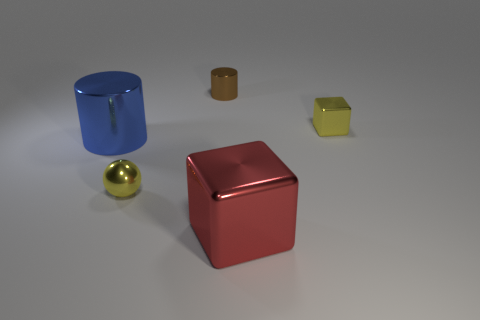Add 5 small metallic spheres. How many objects exist? 10 Subtract all blocks. How many objects are left? 3 Add 5 tiny metallic spheres. How many tiny metallic spheres are left? 6 Add 5 big shiny cylinders. How many big shiny cylinders exist? 6 Subtract 0 cyan balls. How many objects are left? 5 Subtract all big brown balls. Subtract all shiny balls. How many objects are left? 4 